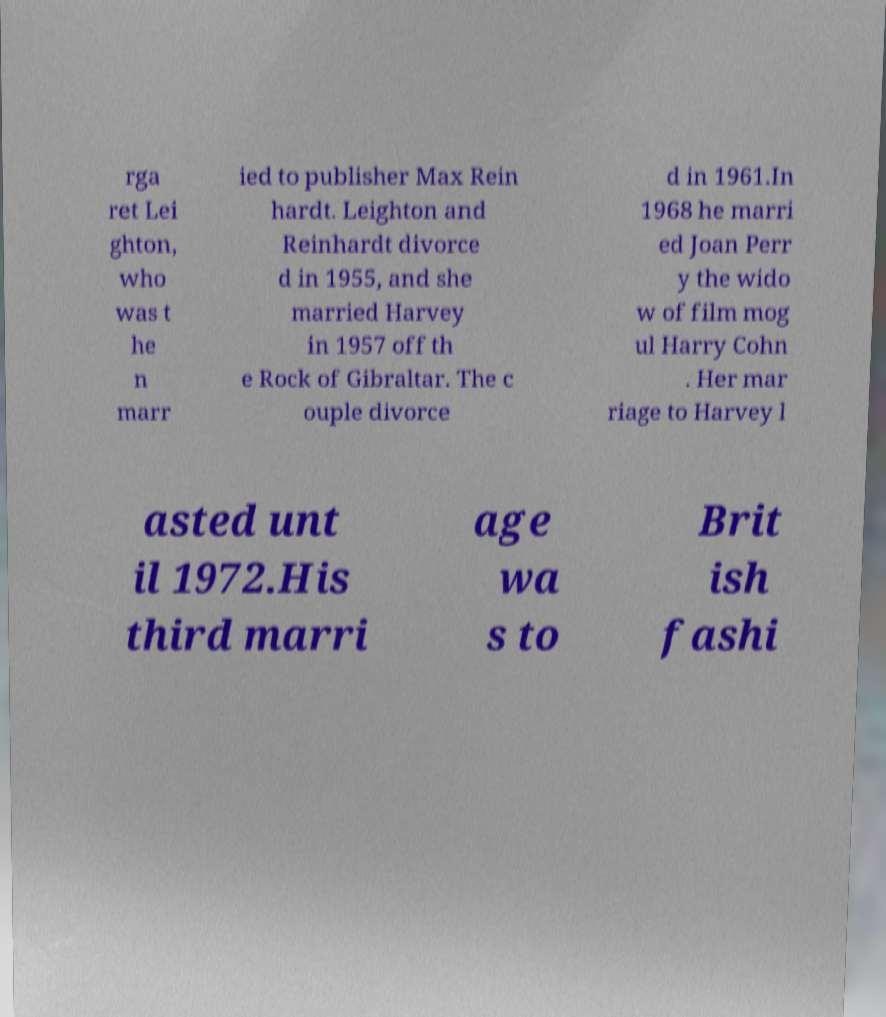Please read and relay the text visible in this image. What does it say? rga ret Lei ghton, who was t he n marr ied to publisher Max Rein hardt. Leighton and Reinhardt divorce d in 1955, and she married Harvey in 1957 off th e Rock of Gibraltar. The c ouple divorce d in 1961.In 1968 he marri ed Joan Perr y the wido w of film mog ul Harry Cohn . Her mar riage to Harvey l asted unt il 1972.His third marri age wa s to Brit ish fashi 